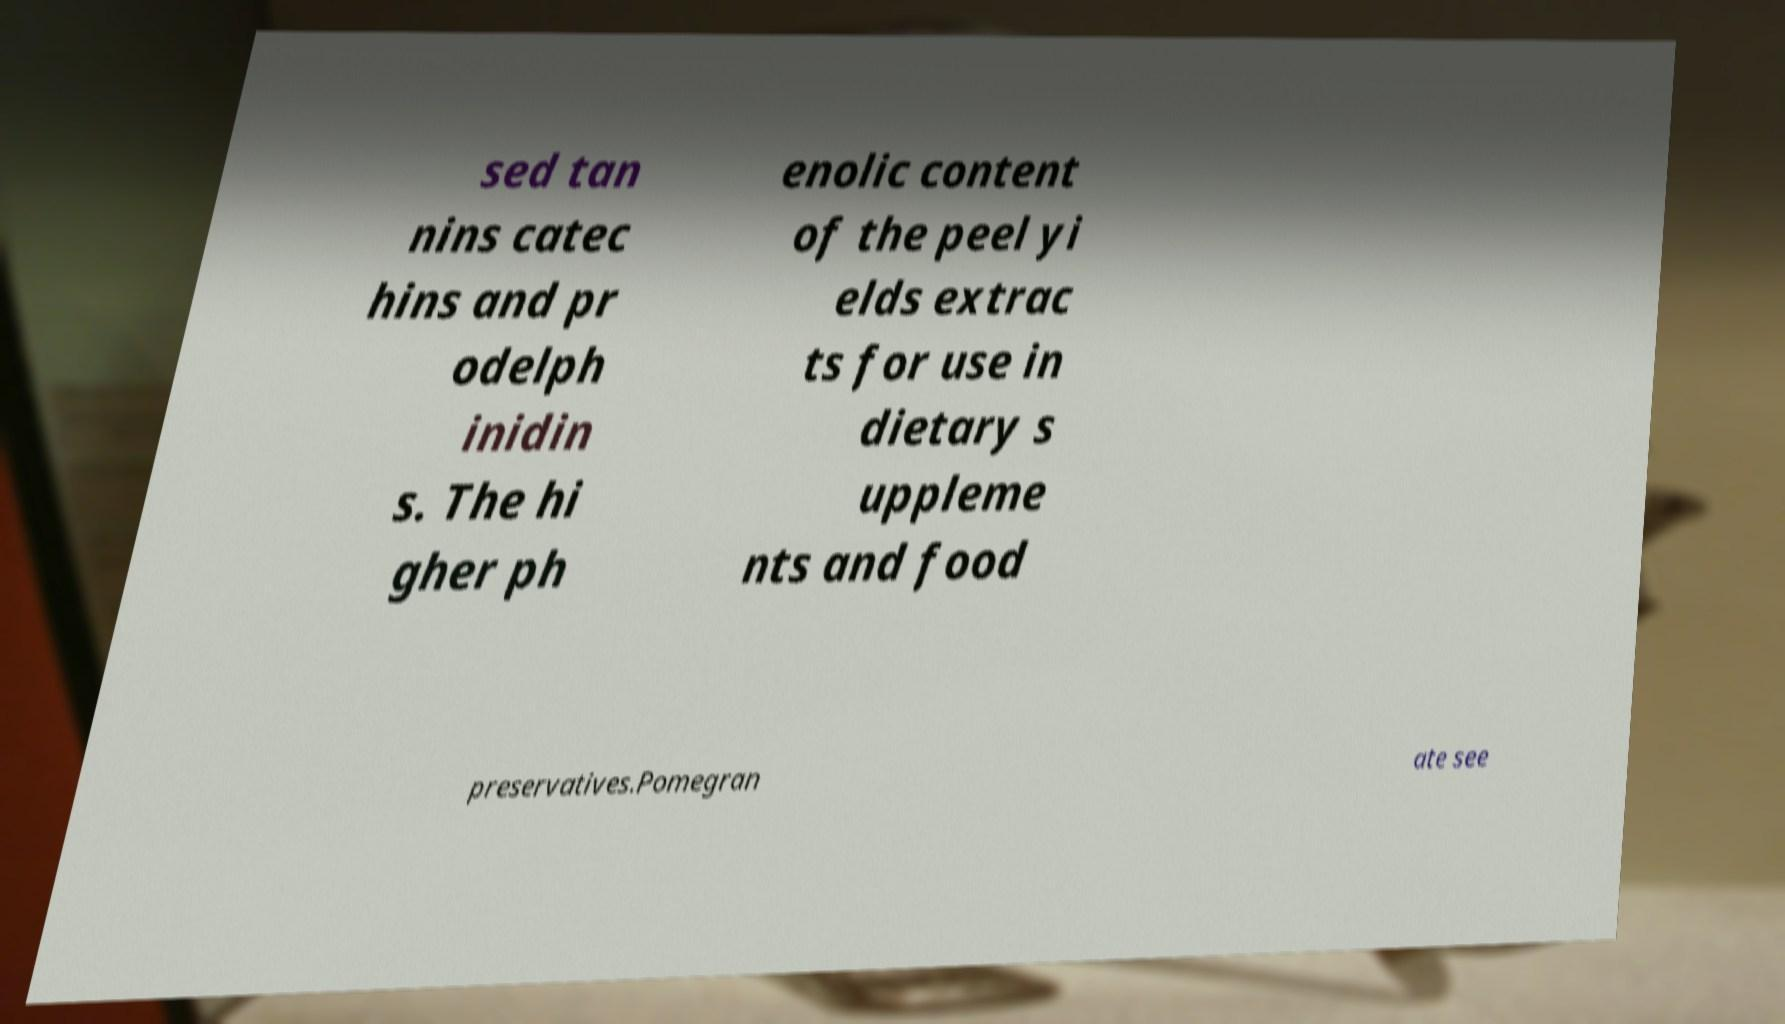What messages or text are displayed in this image? I need them in a readable, typed format. sed tan nins catec hins and pr odelph inidin s. The hi gher ph enolic content of the peel yi elds extrac ts for use in dietary s uppleme nts and food preservatives.Pomegran ate see 